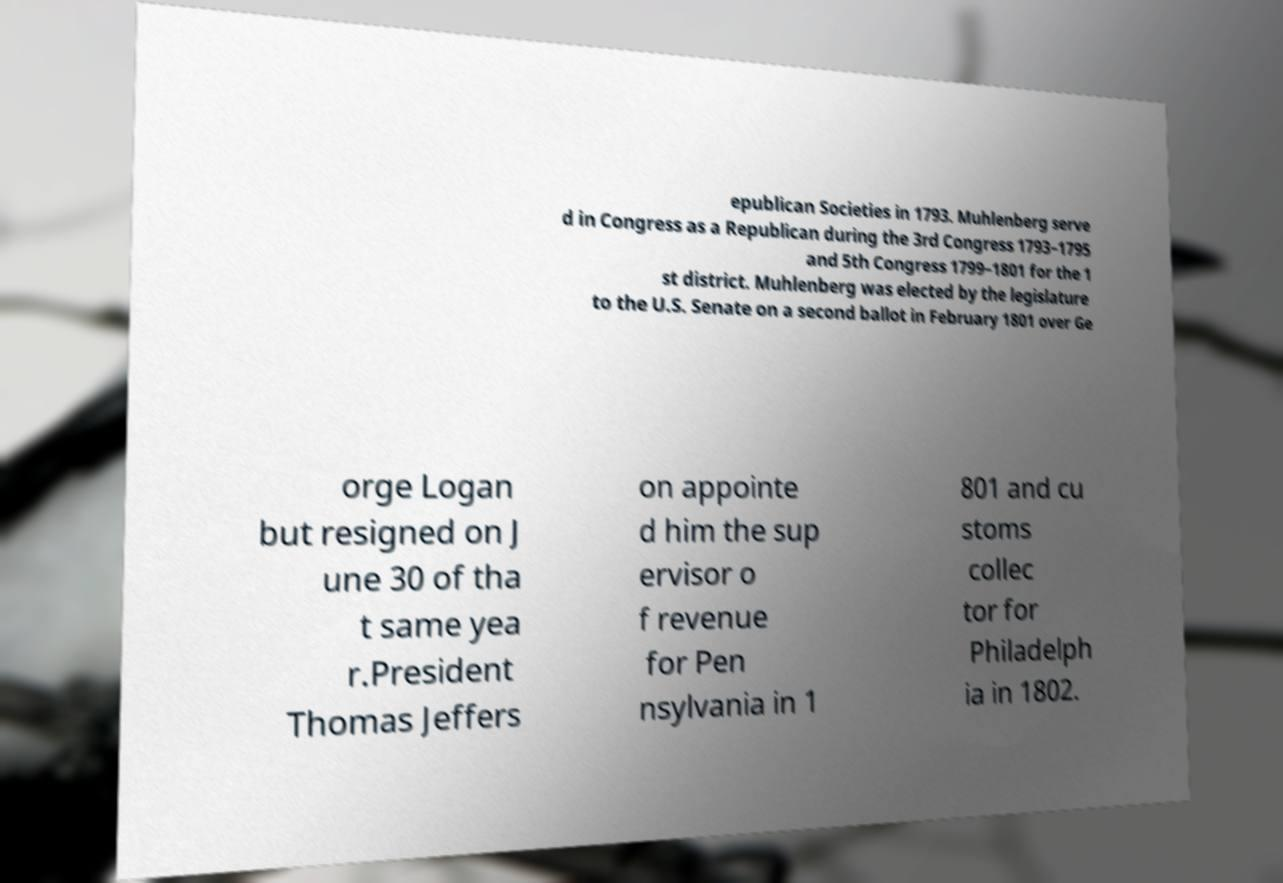I need the written content from this picture converted into text. Can you do that? epublican Societies in 1793. Muhlenberg serve d in Congress as a Republican during the 3rd Congress 1793–1795 and 5th Congress 1799–1801 for the 1 st district. Muhlenberg was elected by the legislature to the U.S. Senate on a second ballot in February 1801 over Ge orge Logan but resigned on J une 30 of tha t same yea r.President Thomas Jeffers on appointe d him the sup ervisor o f revenue for Pen nsylvania in 1 801 and cu stoms collec tor for Philadelph ia in 1802. 